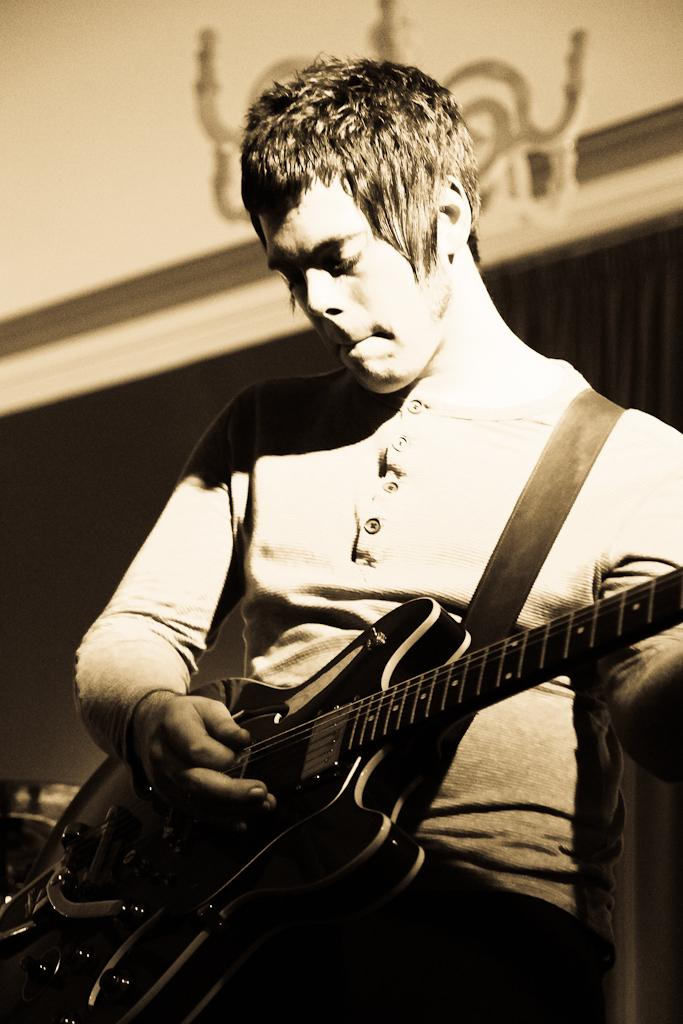What is the main subject of the image? There is a person in the image. What is the person doing in the image? The person is playing a guitar. What type of decision can be seen being made by the clover in the image? There is no clover present in the image, and therefore no decision-making can be observed. 